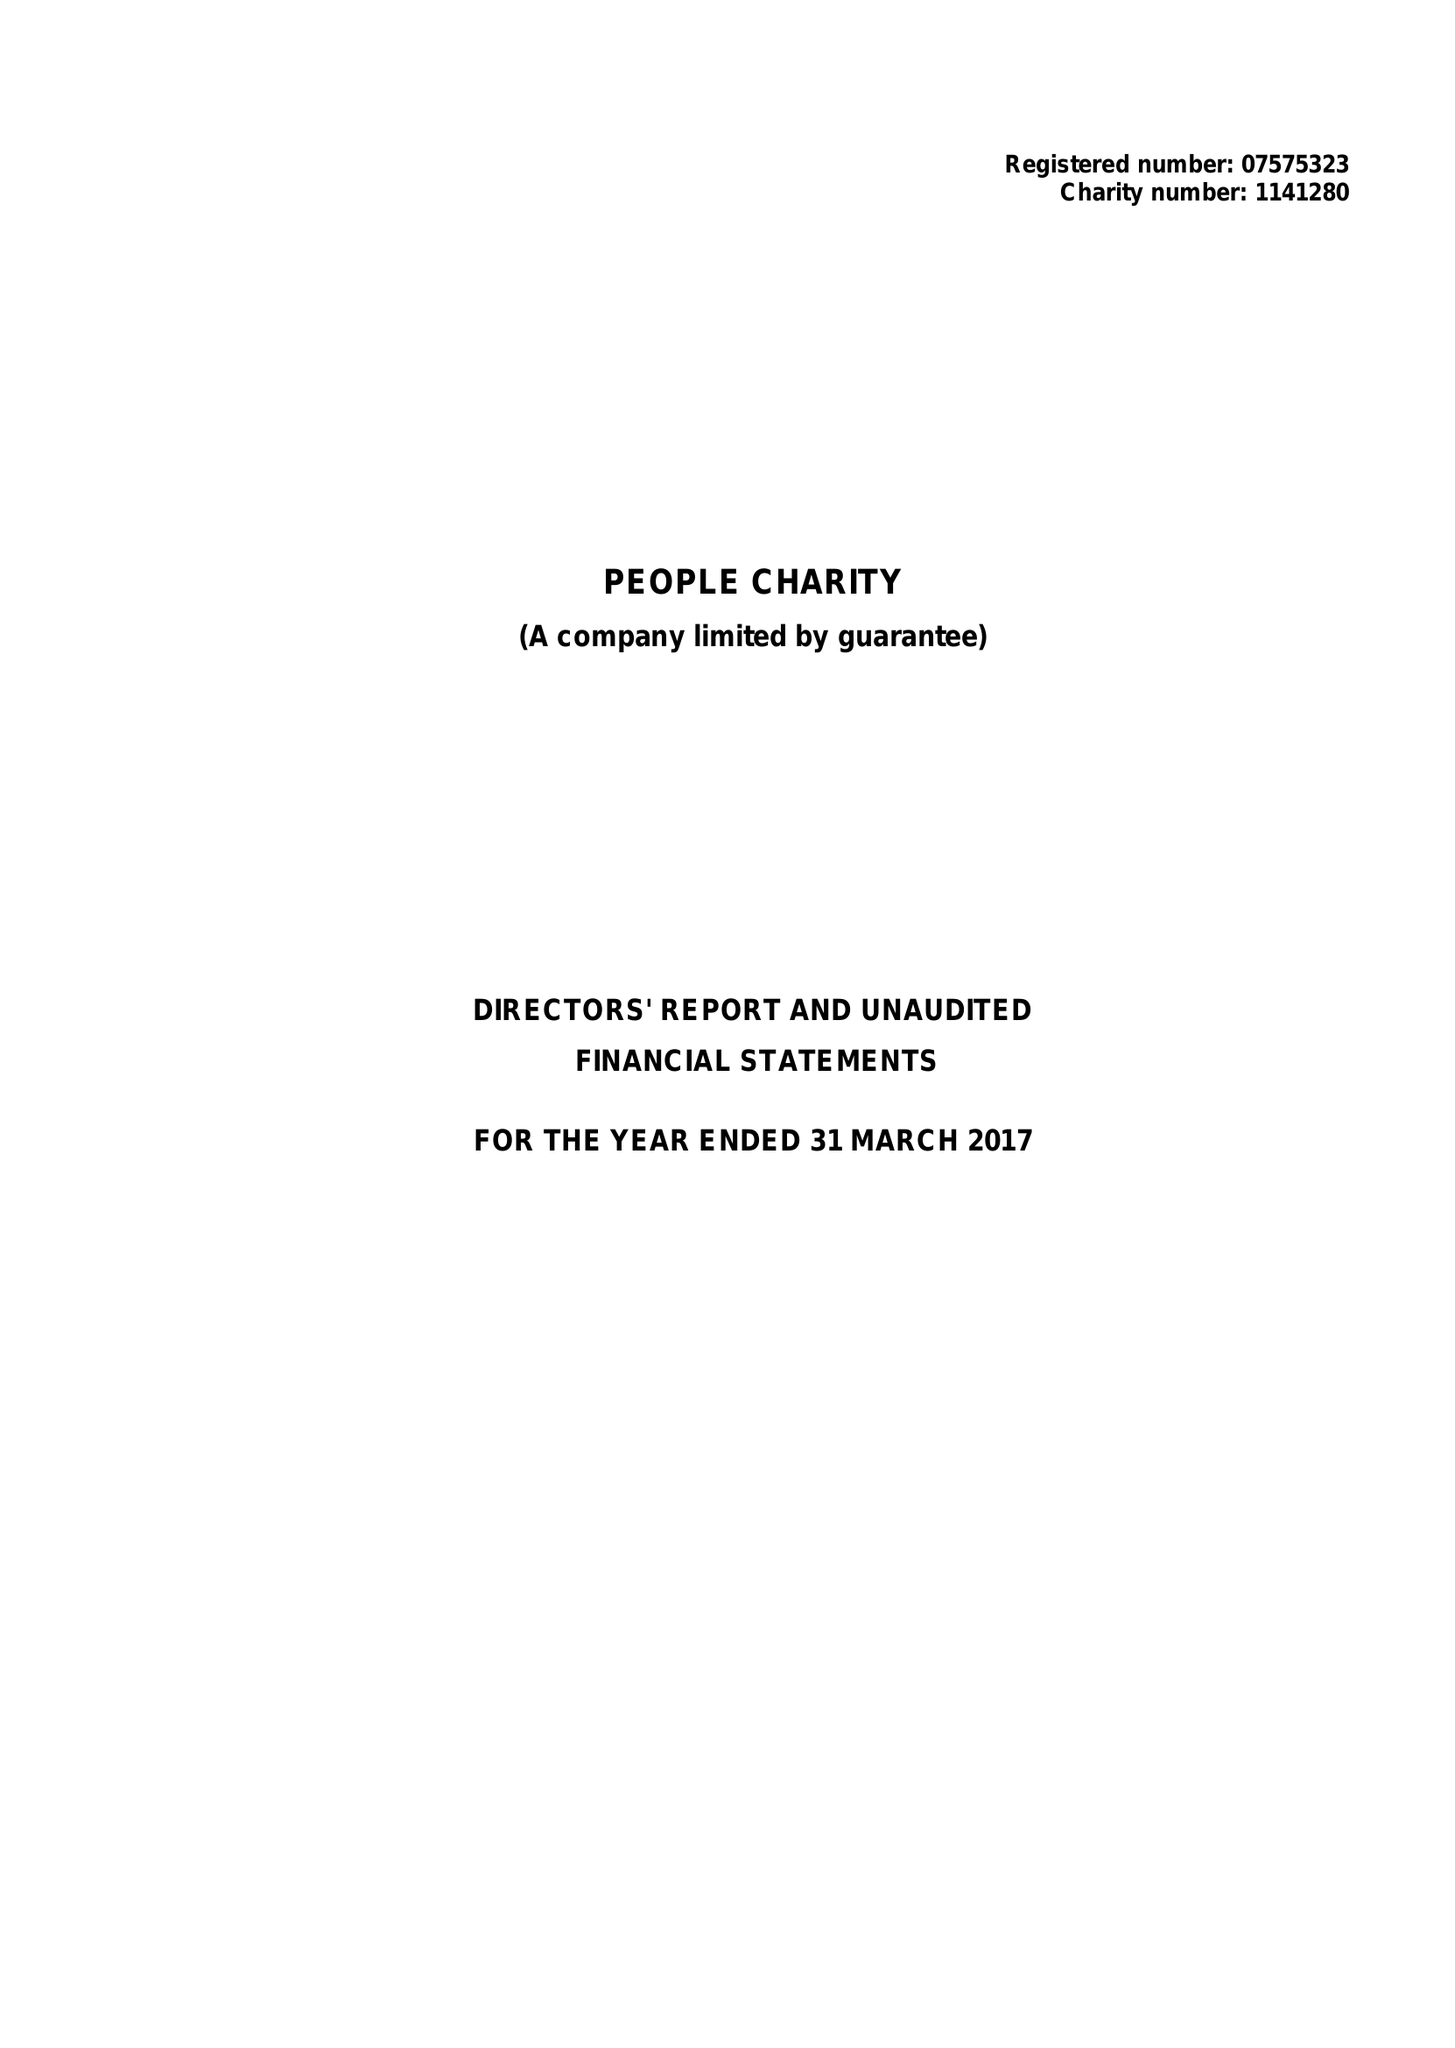What is the value for the charity_name?
Answer the question using a single word or phrase. People Charity 